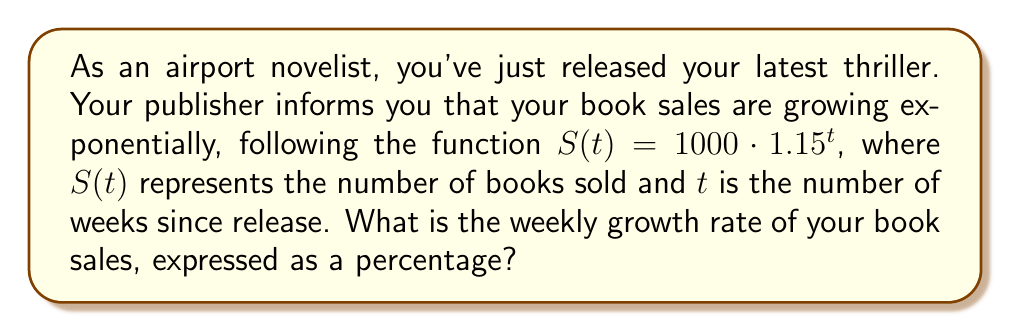What is the answer to this math problem? To find the weekly growth rate, we need to analyze the exponential function given:

$S(t) = 1000 \cdot 1.15^t$

In an exponential growth function of the form $a \cdot b^t$, the base $b$ represents the growth factor. In this case, $b = 1.15$.

The growth rate is how much the quantity increases each period, expressed as a percentage. To calculate this:

1. Subtract 1 from the growth factor:
   $1.15 - 1 = 0.15$

2. Convert to a percentage by multiplying by 100:
   $0.15 \cdot 100 = 15\%$

Therefore, the weekly growth rate is 15%.

This means that each week, the number of books sold increases by 15% compared to the previous week.
Answer: 15% 